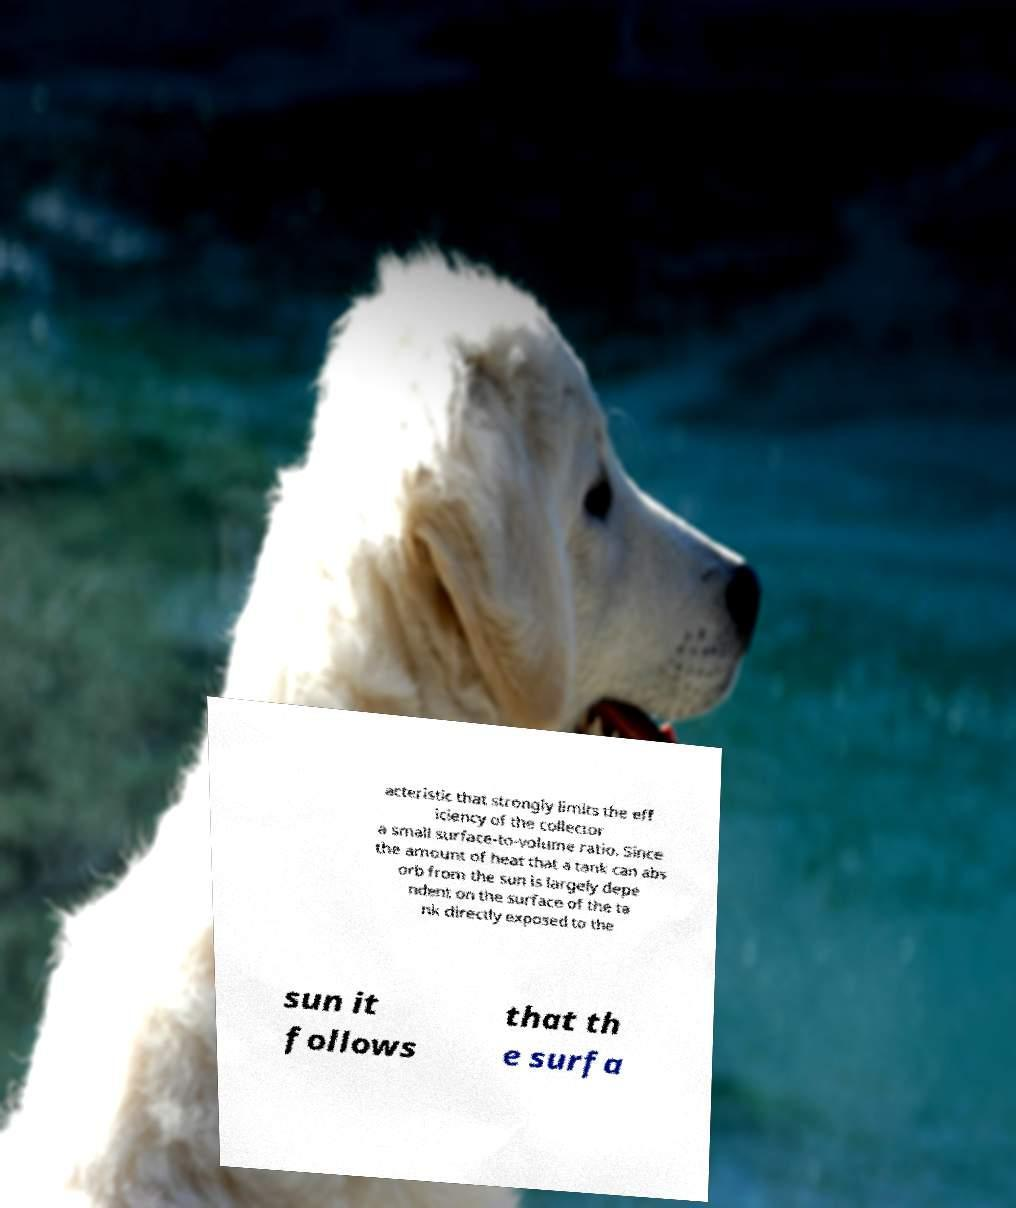For documentation purposes, I need the text within this image transcribed. Could you provide that? acteristic that strongly limits the eff iciency of the collector a small surface-to-volume ratio. Since the amount of heat that a tank can abs orb from the sun is largely depe ndent on the surface of the ta nk directly exposed to the sun it follows that th e surfa 